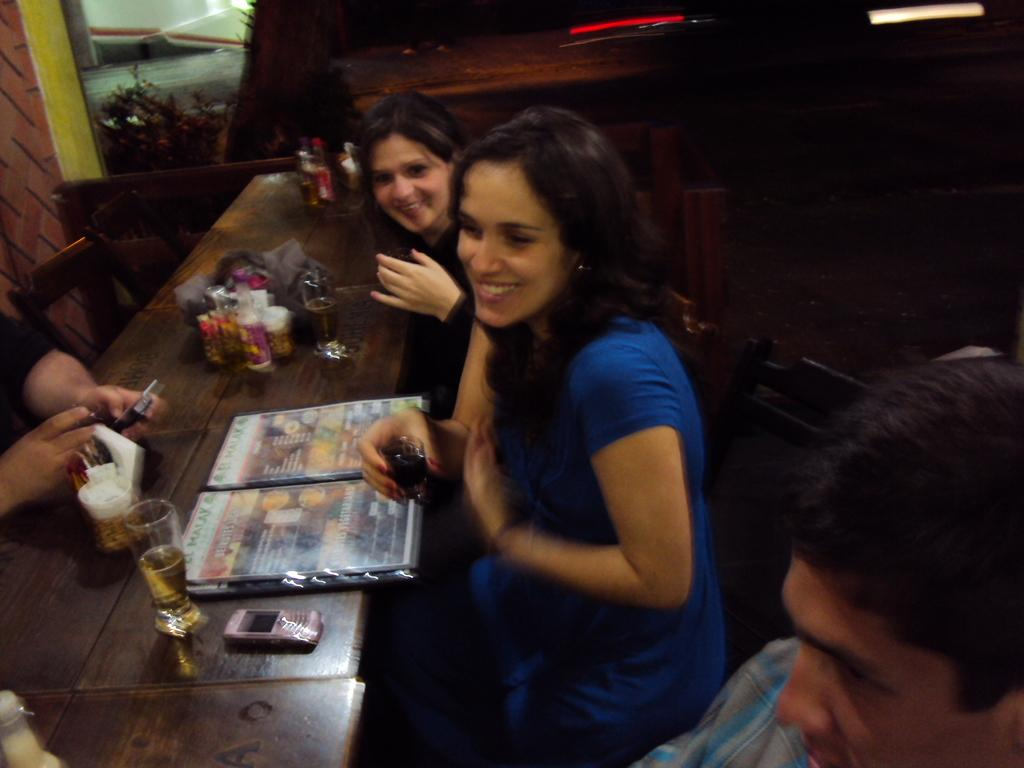What are the ladies in the image doing? The ladies are sitting around a table. What are the ladies holding in their hands? The ladies are holding shot glasses. What can be seen on the table in the image? There are objects on the table. How many times do the ladies sneeze in the image? There is no indication of sneezing in the image; the ladies are holding shot glasses and sitting around a table. 